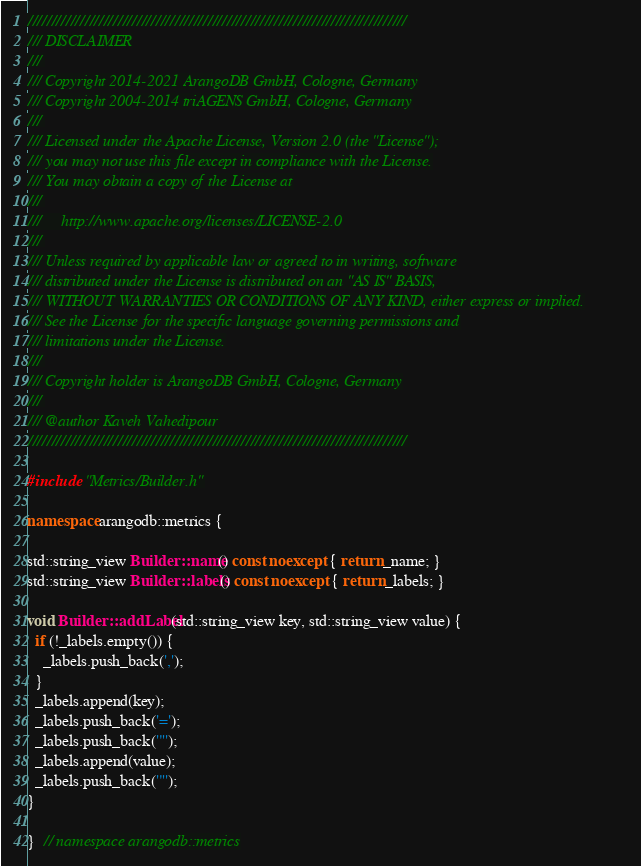<code> <loc_0><loc_0><loc_500><loc_500><_C++_>////////////////////////////////////////////////////////////////////////////////
/// DISCLAIMER
///
/// Copyright 2014-2021 ArangoDB GmbH, Cologne, Germany
/// Copyright 2004-2014 triAGENS GmbH, Cologne, Germany
///
/// Licensed under the Apache License, Version 2.0 (the "License");
/// you may not use this file except in compliance with the License.
/// You may obtain a copy of the License at
///
///     http://www.apache.org/licenses/LICENSE-2.0
///
/// Unless required by applicable law or agreed to in writing, software
/// distributed under the License is distributed on an "AS IS" BASIS,
/// WITHOUT WARRANTIES OR CONDITIONS OF ANY KIND, either express or implied.
/// See the License for the specific language governing permissions and
/// limitations under the License.
///
/// Copyright holder is ArangoDB GmbH, Cologne, Germany
///
/// @author Kaveh Vahedipour
////////////////////////////////////////////////////////////////////////////////

#include "Metrics/Builder.h"

namespace arangodb::metrics {

std::string_view Builder::name() const noexcept { return _name; }
std::string_view Builder::labels() const noexcept { return _labels; }

void Builder::addLabel(std::string_view key, std::string_view value) {
  if (!_labels.empty()) {
    _labels.push_back(',');
  }
  _labels.append(key);
  _labels.push_back('=');
  _labels.push_back('"');
  _labels.append(value);
  _labels.push_back('"');
}

}  // namespace arangodb::metrics
</code> 